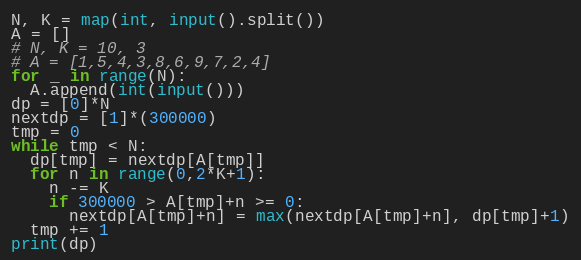<code> <loc_0><loc_0><loc_500><loc_500><_Python_>N, K = map(int, input().split())
A = []
# N, K = 10, 3
# A = [1,5,4,3,8,6,9,7,2,4]
for _ in range(N):
  A.append(int(input()))
dp = [0]*N
nextdp = [1]*(300000)
tmp = 0
while tmp < N:
  dp[tmp] = nextdp[A[tmp]]
  for n in range(0,2*K+1):
    n -= K
    if 300000 > A[tmp]+n >= 0:
      nextdp[A[tmp]+n] = max(nextdp[A[tmp]+n], dp[tmp]+1)
  tmp += 1
print(dp)</code> 